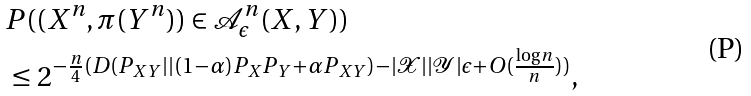Convert formula to latex. <formula><loc_0><loc_0><loc_500><loc_500>& P ( ( X ^ { n } , \pi ( Y ^ { n } ) ) \in \mathcal { A } _ { \epsilon } ^ { n } ( X , Y ) ) \\ & \leq 2 ^ { - \frac { n } { 4 } ( D ( P _ { X Y } | | ( 1 - \alpha ) P _ { X } P _ { Y } + \alpha P _ { X Y } ) - | \mathcal { X } | | \mathcal { Y } | \epsilon + O ( \frac { \log { n } } { n } ) ) } ,</formula> 